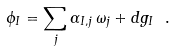<formula> <loc_0><loc_0><loc_500><loc_500>\phi _ { I } = \sum _ { j } \alpha _ { I , j } \, \omega _ { j } + d g _ { I } \ .</formula> 